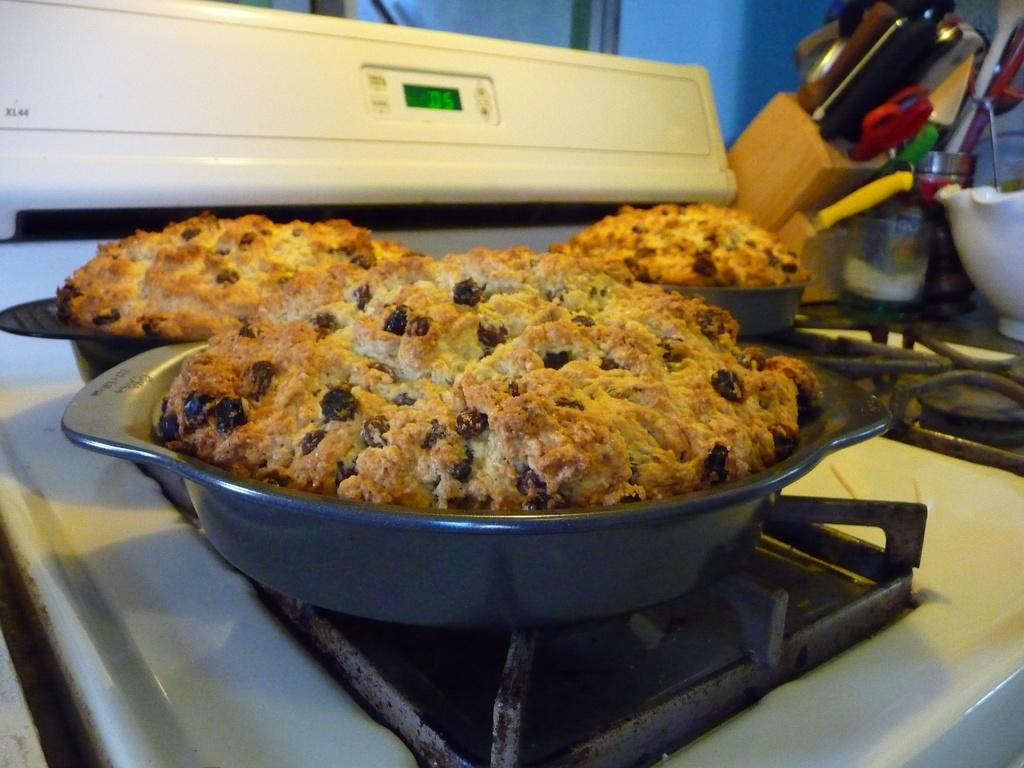What is on the trays that are visible in the image? There are cookies on trays in the image. Where are the trays with cookies located? The trays are on top of the stove. What tools are beside the stove in the image? There are knives and scissors beside the stove. What other objects can be seen beside the stove? There are other objects beside the stove, but their specific details are not mentioned in the provided facts. Can you see any icicles hanging from the board in the image? There is no board or icicles present in the image. 